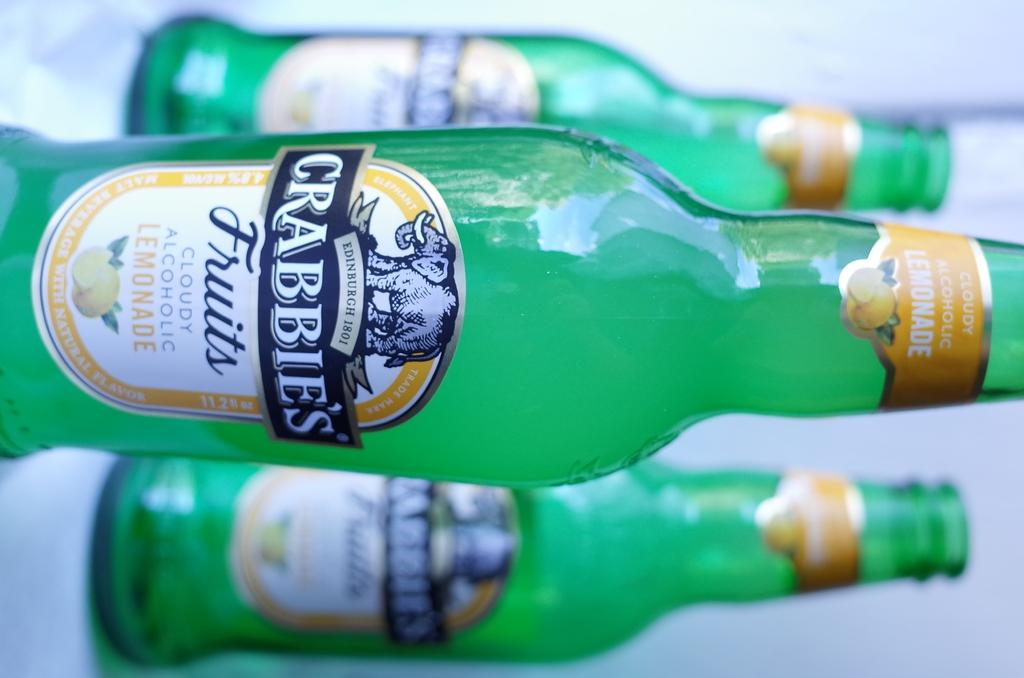<image>
Summarize the visual content of the image. Three green bottles are labelled as Crabbie's cloudy alcoholic lemonade. 